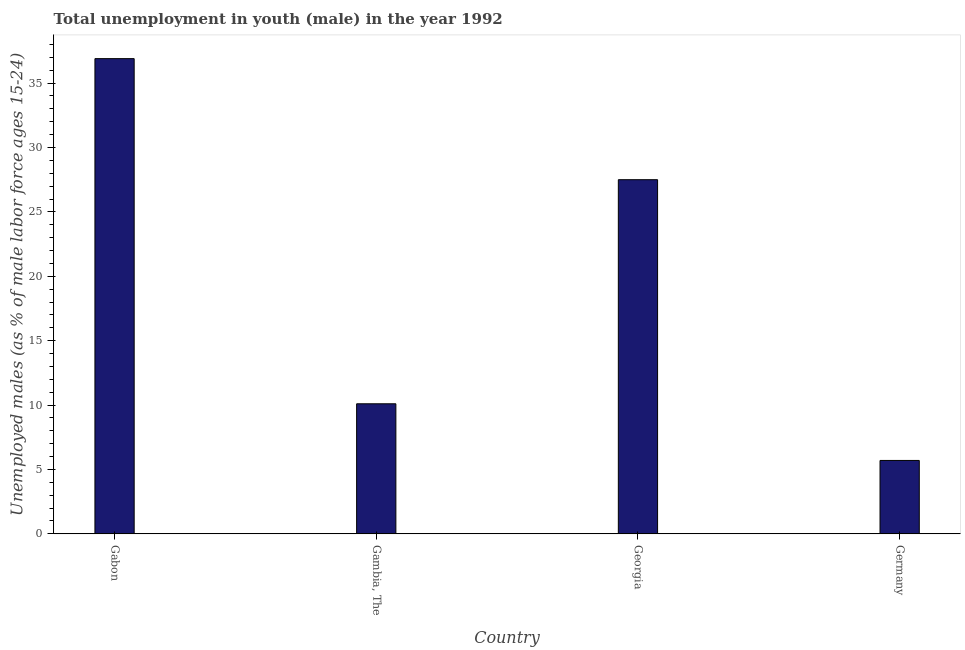Does the graph contain any zero values?
Provide a short and direct response. No. Does the graph contain grids?
Your response must be concise. No. What is the title of the graph?
Offer a very short reply. Total unemployment in youth (male) in the year 1992. What is the label or title of the X-axis?
Give a very brief answer. Country. What is the label or title of the Y-axis?
Provide a succinct answer. Unemployed males (as % of male labor force ages 15-24). What is the unemployed male youth population in Georgia?
Make the answer very short. 27.5. Across all countries, what is the maximum unemployed male youth population?
Your answer should be very brief. 36.9. Across all countries, what is the minimum unemployed male youth population?
Your answer should be very brief. 5.7. In which country was the unemployed male youth population maximum?
Offer a very short reply. Gabon. In which country was the unemployed male youth population minimum?
Your answer should be compact. Germany. What is the sum of the unemployed male youth population?
Keep it short and to the point. 80.2. What is the difference between the unemployed male youth population in Georgia and Germany?
Keep it short and to the point. 21.8. What is the average unemployed male youth population per country?
Your answer should be compact. 20.05. What is the median unemployed male youth population?
Your response must be concise. 18.8. What is the ratio of the unemployed male youth population in Gambia, The to that in Germany?
Your response must be concise. 1.77. Is the unemployed male youth population in Gabon less than that in Georgia?
Provide a short and direct response. No. What is the difference between the highest and the lowest unemployed male youth population?
Your answer should be compact. 31.2. In how many countries, is the unemployed male youth population greater than the average unemployed male youth population taken over all countries?
Offer a terse response. 2. How many bars are there?
Ensure brevity in your answer.  4. Are all the bars in the graph horizontal?
Ensure brevity in your answer.  No. What is the Unemployed males (as % of male labor force ages 15-24) of Gabon?
Keep it short and to the point. 36.9. What is the Unemployed males (as % of male labor force ages 15-24) in Gambia, The?
Ensure brevity in your answer.  10.1. What is the Unemployed males (as % of male labor force ages 15-24) in Germany?
Offer a very short reply. 5.7. What is the difference between the Unemployed males (as % of male labor force ages 15-24) in Gabon and Gambia, The?
Your response must be concise. 26.8. What is the difference between the Unemployed males (as % of male labor force ages 15-24) in Gabon and Germany?
Offer a very short reply. 31.2. What is the difference between the Unemployed males (as % of male labor force ages 15-24) in Gambia, The and Georgia?
Keep it short and to the point. -17.4. What is the difference between the Unemployed males (as % of male labor force ages 15-24) in Gambia, The and Germany?
Keep it short and to the point. 4.4. What is the difference between the Unemployed males (as % of male labor force ages 15-24) in Georgia and Germany?
Your response must be concise. 21.8. What is the ratio of the Unemployed males (as % of male labor force ages 15-24) in Gabon to that in Gambia, The?
Your answer should be compact. 3.65. What is the ratio of the Unemployed males (as % of male labor force ages 15-24) in Gabon to that in Georgia?
Give a very brief answer. 1.34. What is the ratio of the Unemployed males (as % of male labor force ages 15-24) in Gabon to that in Germany?
Keep it short and to the point. 6.47. What is the ratio of the Unemployed males (as % of male labor force ages 15-24) in Gambia, The to that in Georgia?
Make the answer very short. 0.37. What is the ratio of the Unemployed males (as % of male labor force ages 15-24) in Gambia, The to that in Germany?
Offer a terse response. 1.77. What is the ratio of the Unemployed males (as % of male labor force ages 15-24) in Georgia to that in Germany?
Offer a very short reply. 4.83. 